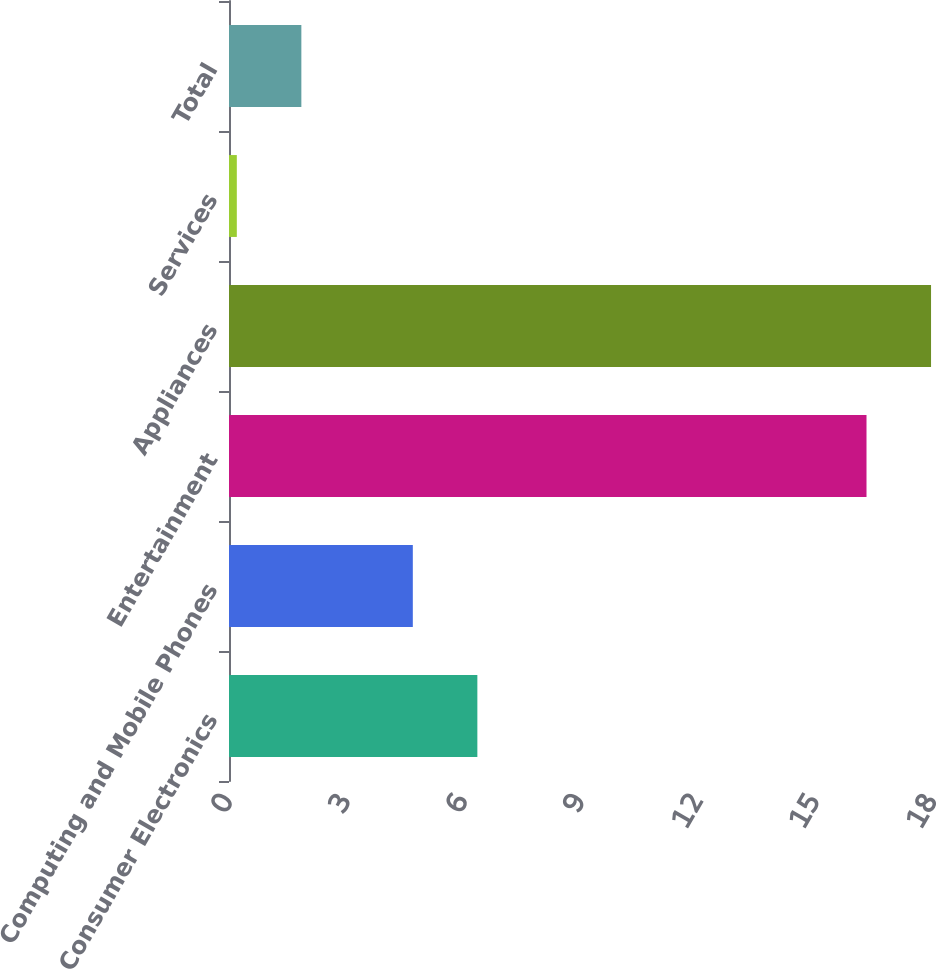Convert chart to OTSL. <chart><loc_0><loc_0><loc_500><loc_500><bar_chart><fcel>Consumer Electronics<fcel>Computing and Mobile Phones<fcel>Entertainment<fcel>Appliances<fcel>Services<fcel>Total<nl><fcel>6.35<fcel>4.7<fcel>16.3<fcel>17.95<fcel>0.2<fcel>1.85<nl></chart> 